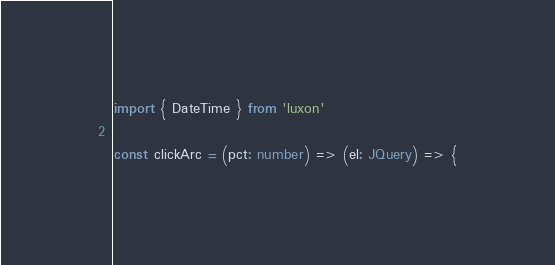Convert code to text. <code><loc_0><loc_0><loc_500><loc_500><_TypeScript_>import { DateTime } from 'luxon'

const clickArc = (pct: number) => (el: JQuery) => {</code> 